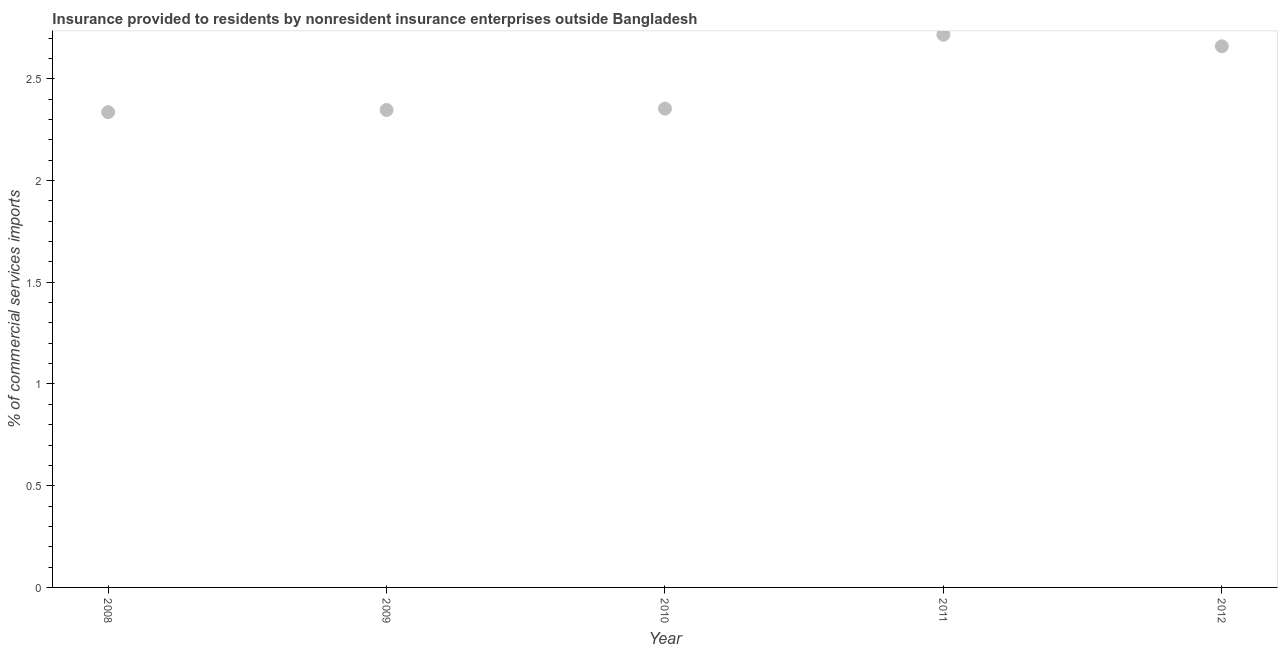What is the insurance provided by non-residents in 2008?
Provide a succinct answer. 2.34. Across all years, what is the maximum insurance provided by non-residents?
Make the answer very short. 2.72. Across all years, what is the minimum insurance provided by non-residents?
Offer a very short reply. 2.34. What is the sum of the insurance provided by non-residents?
Provide a short and direct response. 12.41. What is the difference between the insurance provided by non-residents in 2009 and 2012?
Make the answer very short. -0.31. What is the average insurance provided by non-residents per year?
Provide a succinct answer. 2.48. What is the median insurance provided by non-residents?
Give a very brief answer. 2.35. In how many years, is the insurance provided by non-residents greater than 2.5 %?
Provide a short and direct response. 2. What is the ratio of the insurance provided by non-residents in 2011 to that in 2012?
Ensure brevity in your answer.  1.02. Is the insurance provided by non-residents in 2009 less than that in 2011?
Give a very brief answer. Yes. Is the difference between the insurance provided by non-residents in 2010 and 2011 greater than the difference between any two years?
Keep it short and to the point. No. What is the difference between the highest and the second highest insurance provided by non-residents?
Your answer should be very brief. 0.06. What is the difference between the highest and the lowest insurance provided by non-residents?
Offer a very short reply. 0.38. How many dotlines are there?
Provide a succinct answer. 1. What is the difference between two consecutive major ticks on the Y-axis?
Ensure brevity in your answer.  0.5. Are the values on the major ticks of Y-axis written in scientific E-notation?
Keep it short and to the point. No. Does the graph contain any zero values?
Your answer should be compact. No. Does the graph contain grids?
Keep it short and to the point. No. What is the title of the graph?
Make the answer very short. Insurance provided to residents by nonresident insurance enterprises outside Bangladesh. What is the label or title of the X-axis?
Ensure brevity in your answer.  Year. What is the label or title of the Y-axis?
Provide a succinct answer. % of commercial services imports. What is the % of commercial services imports in 2008?
Offer a terse response. 2.34. What is the % of commercial services imports in 2009?
Give a very brief answer. 2.35. What is the % of commercial services imports in 2010?
Keep it short and to the point. 2.35. What is the % of commercial services imports in 2011?
Keep it short and to the point. 2.72. What is the % of commercial services imports in 2012?
Keep it short and to the point. 2.66. What is the difference between the % of commercial services imports in 2008 and 2009?
Keep it short and to the point. -0.01. What is the difference between the % of commercial services imports in 2008 and 2010?
Your response must be concise. -0.02. What is the difference between the % of commercial services imports in 2008 and 2011?
Offer a very short reply. -0.38. What is the difference between the % of commercial services imports in 2008 and 2012?
Your response must be concise. -0.32. What is the difference between the % of commercial services imports in 2009 and 2010?
Provide a succinct answer. -0.01. What is the difference between the % of commercial services imports in 2009 and 2011?
Your response must be concise. -0.37. What is the difference between the % of commercial services imports in 2009 and 2012?
Your answer should be compact. -0.31. What is the difference between the % of commercial services imports in 2010 and 2011?
Your answer should be compact. -0.36. What is the difference between the % of commercial services imports in 2010 and 2012?
Make the answer very short. -0.31. What is the difference between the % of commercial services imports in 2011 and 2012?
Ensure brevity in your answer.  0.06. What is the ratio of the % of commercial services imports in 2008 to that in 2010?
Give a very brief answer. 0.99. What is the ratio of the % of commercial services imports in 2008 to that in 2011?
Ensure brevity in your answer.  0.86. What is the ratio of the % of commercial services imports in 2008 to that in 2012?
Give a very brief answer. 0.88. What is the ratio of the % of commercial services imports in 2009 to that in 2011?
Your answer should be compact. 0.86. What is the ratio of the % of commercial services imports in 2009 to that in 2012?
Provide a short and direct response. 0.88. What is the ratio of the % of commercial services imports in 2010 to that in 2011?
Provide a short and direct response. 0.87. What is the ratio of the % of commercial services imports in 2010 to that in 2012?
Your answer should be very brief. 0.89. What is the ratio of the % of commercial services imports in 2011 to that in 2012?
Offer a very short reply. 1.02. 